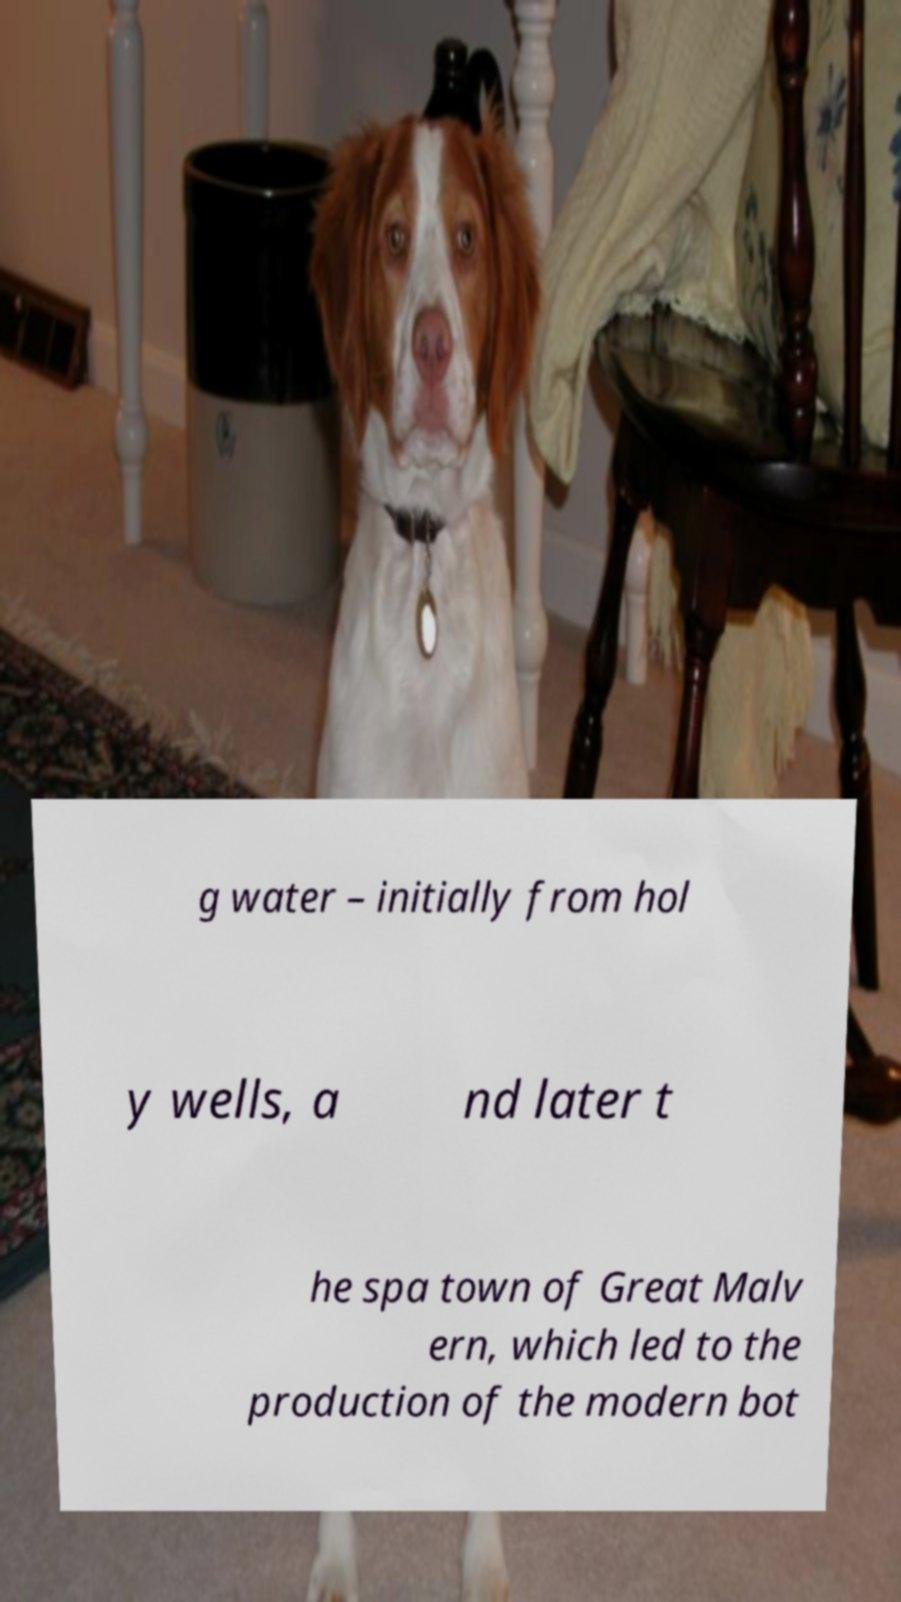Please read and relay the text visible in this image. What does it say? g water – initially from hol y wells, a nd later t he spa town of Great Malv ern, which led to the production of the modern bot 